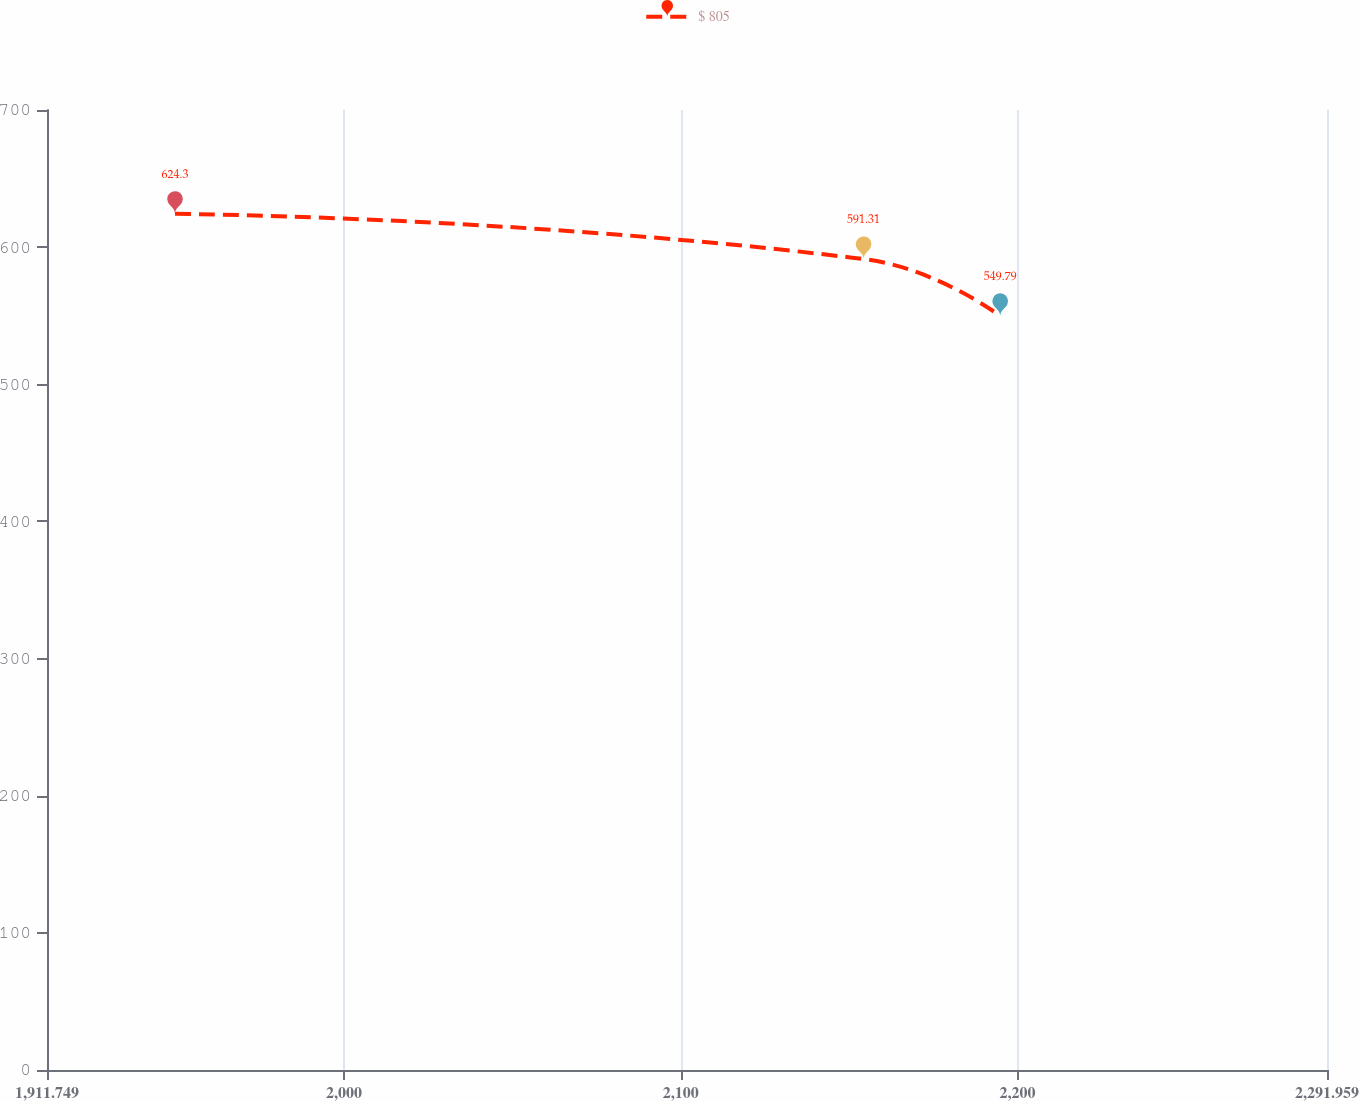Convert chart. <chart><loc_0><loc_0><loc_500><loc_500><line_chart><ecel><fcel>$ 805<nl><fcel>1949.77<fcel>624.3<nl><fcel>2154.31<fcel>591.31<nl><fcel>2194.89<fcel>549.79<nl><fcel>2329.98<fcel>610.47<nl></chart> 